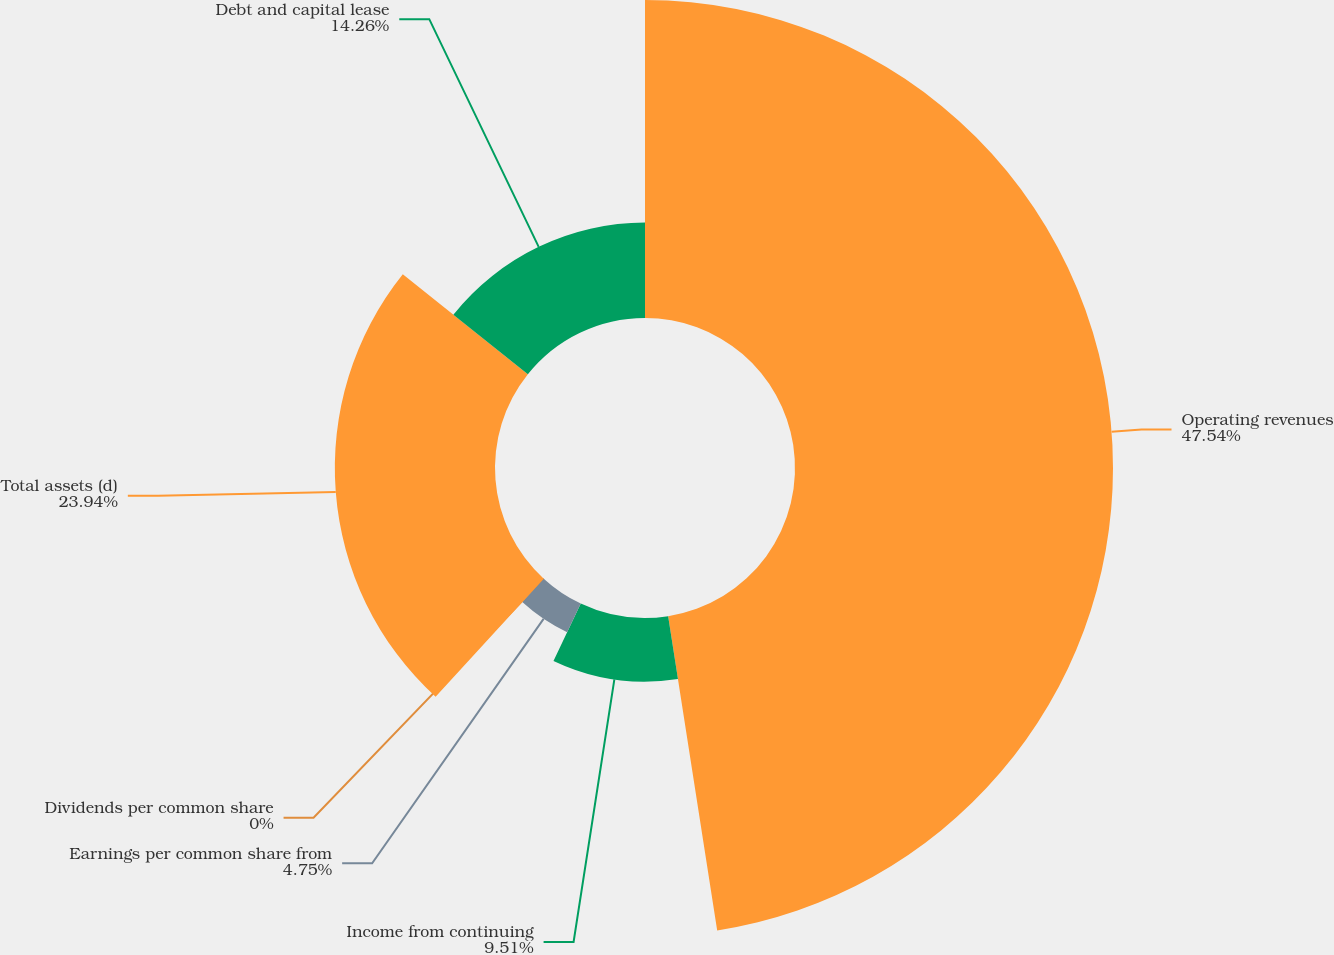<chart> <loc_0><loc_0><loc_500><loc_500><pie_chart><fcel>Operating revenues<fcel>Income from continuing<fcel>Earnings per common share from<fcel>Dividends per common share<fcel>Total assets (d)<fcel>Debt and capital lease<nl><fcel>47.53%<fcel>9.51%<fcel>4.75%<fcel>0.0%<fcel>23.94%<fcel>14.26%<nl></chart> 